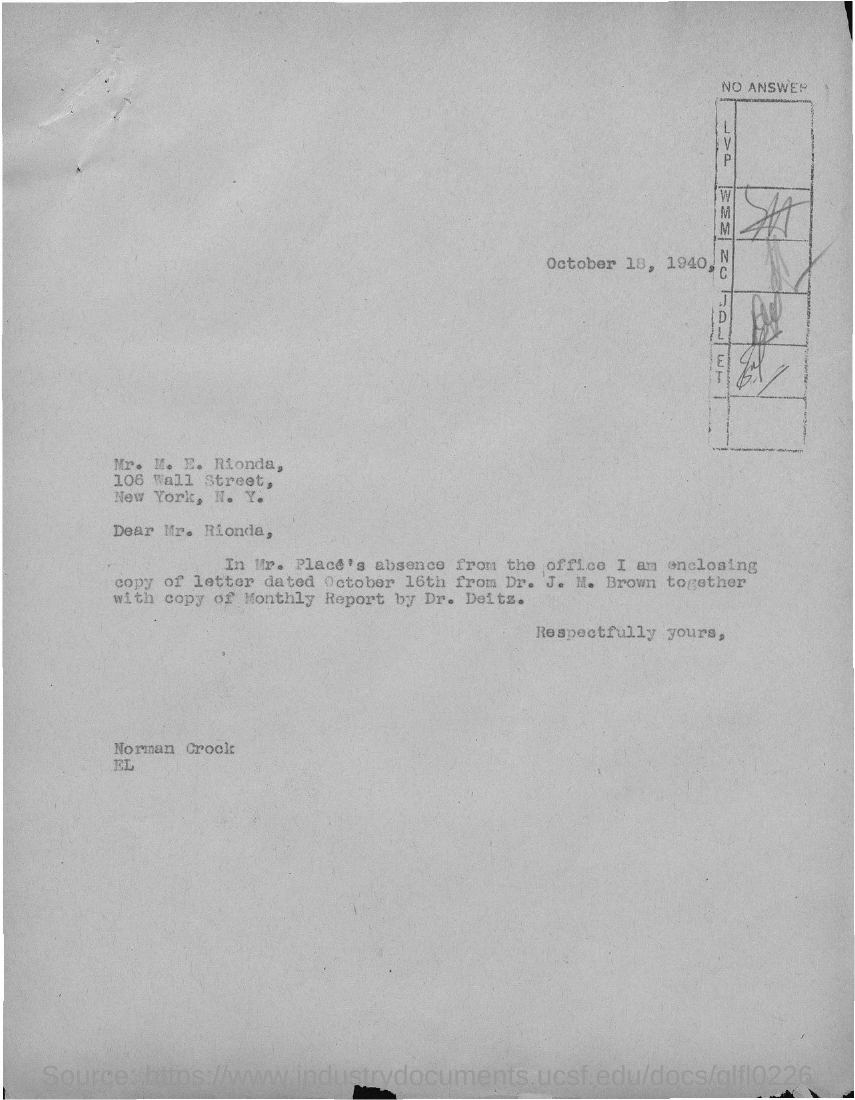To whom is this letter written to?
Your answer should be compact. Mr. rionda. When is the letter dated ?
Provide a succinct answer. October 18, 1940,. 